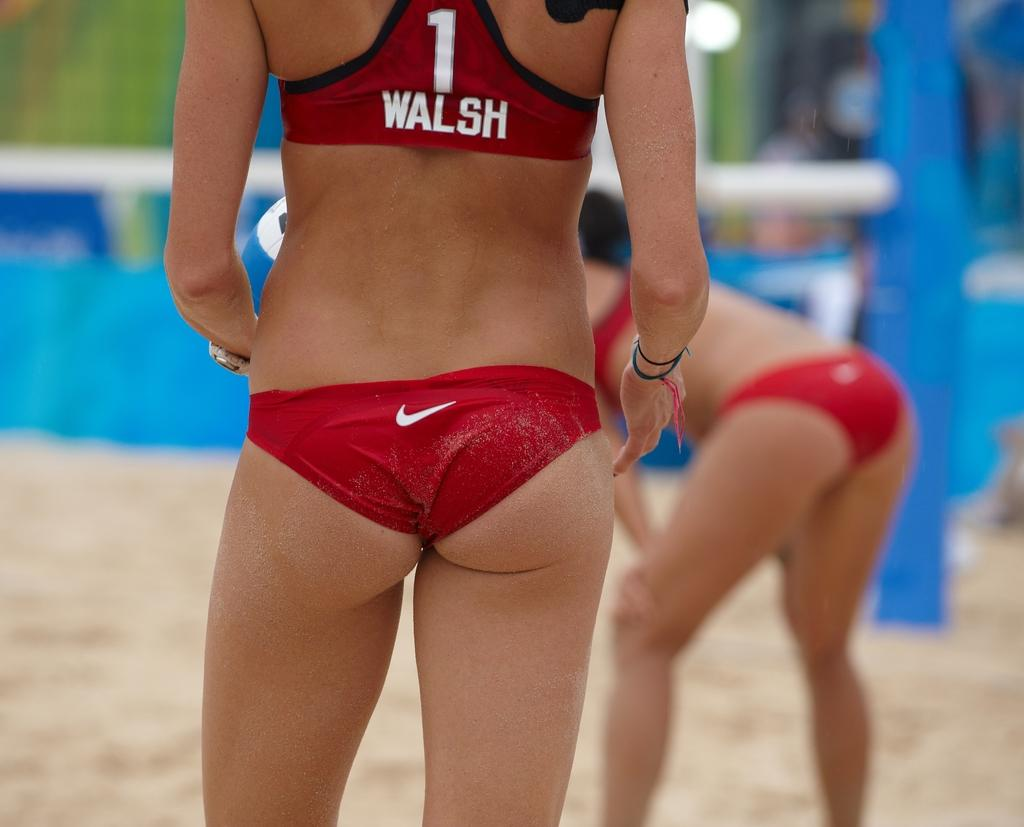What is the main subject of the image? There is a lady standing in the image. What type of surface is at the bottom of the image? There is sand at the bottom of the image. What can be seen in the background of the image? There is a board in the background of the image. How does the wren contribute to the thrill in the image? There is no wren present in the image, and therefore it cannot contribute to any thrill. 